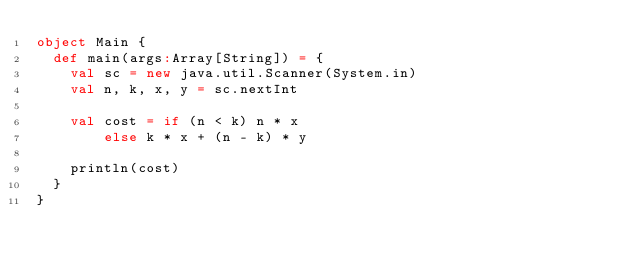<code> <loc_0><loc_0><loc_500><loc_500><_Scala_>object Main {
  def main(args:Array[String]) = {
    val sc = new java.util.Scanner(System.in)
    val n, k, x, y = sc.nextInt

    val cost = if (n < k) n * x
    	else k * x + (n - k) * y

    println(cost)
  }
}</code> 